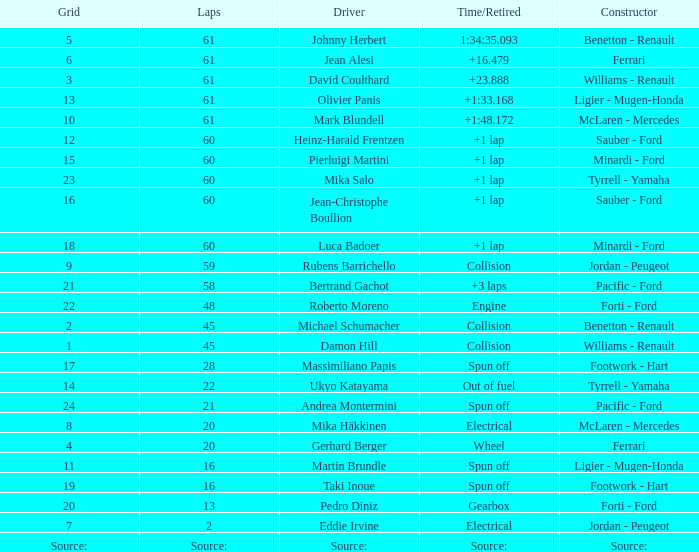What grid has 2 laps? 7.0. 